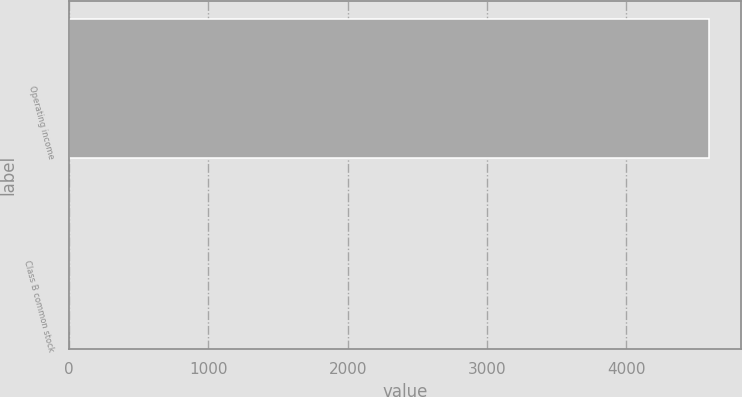<chart> <loc_0><loc_0><loc_500><loc_500><bar_chart><fcel>Operating income<fcel>Class B common stock<nl><fcel>4589<fcel>2.31<nl></chart> 